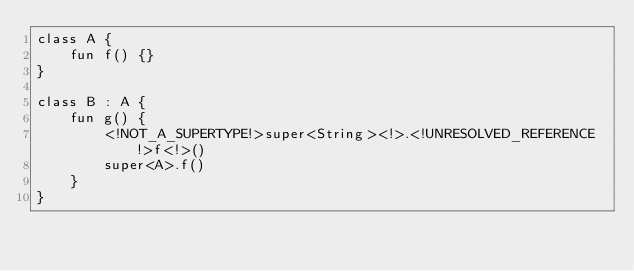<code> <loc_0><loc_0><loc_500><loc_500><_Kotlin_>class A {
    fun f() {}
}

class B : A {
    fun g() {
        <!NOT_A_SUPERTYPE!>super<String><!>.<!UNRESOLVED_REFERENCE!>f<!>()
        super<A>.f()
    }
}</code> 